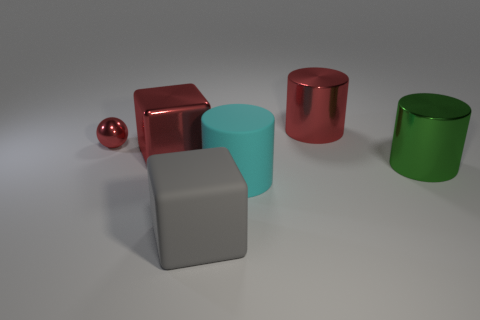Subtract all large matte cylinders. How many cylinders are left? 2 Add 3 red metallic cubes. How many objects exist? 9 Subtract all red cylinders. How many cylinders are left? 2 Subtract all red metallic things. Subtract all gray things. How many objects are left? 2 Add 1 red shiny objects. How many red shiny objects are left? 4 Add 1 large purple rubber cylinders. How many large purple rubber cylinders exist? 1 Subtract 0 yellow balls. How many objects are left? 6 Subtract all balls. How many objects are left? 5 Subtract 1 blocks. How many blocks are left? 1 Subtract all brown cylinders. Subtract all cyan cubes. How many cylinders are left? 3 